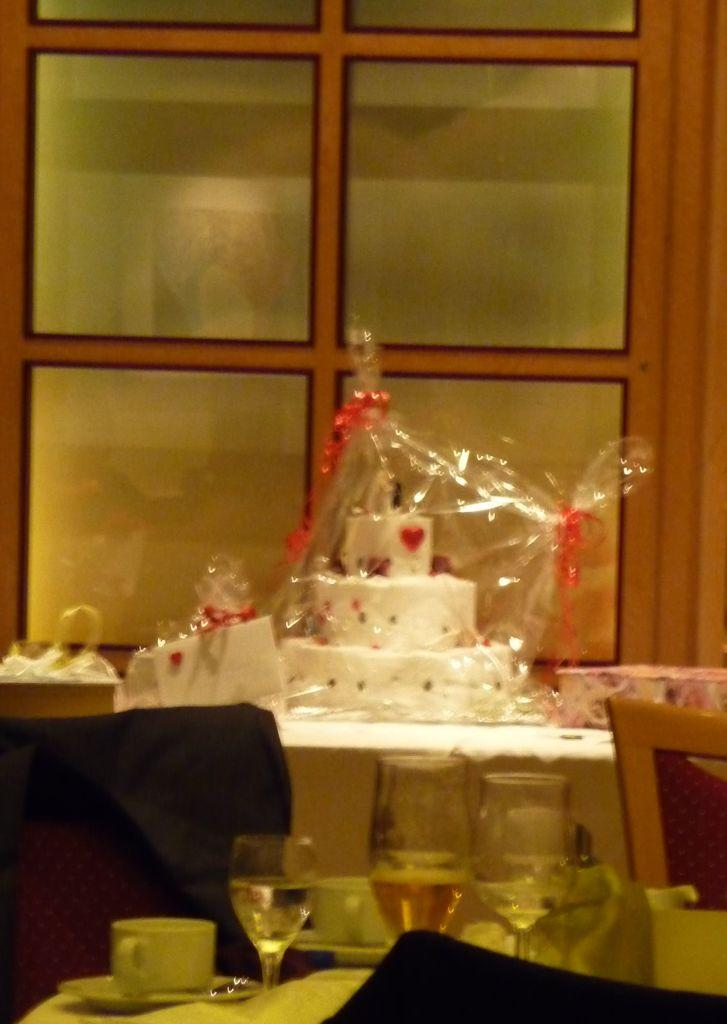What is on the table in the image? There is a cake on the table. What type of furniture is visible in the image? There is a chair in the image. What can be used for drinking in the image? There are glasses and cups on the table. How many babies are sitting in the basket in the image? There is no basket or babies present in the image. What type of trees can be seen through the window in the image? There is no window or trees present in the image. 